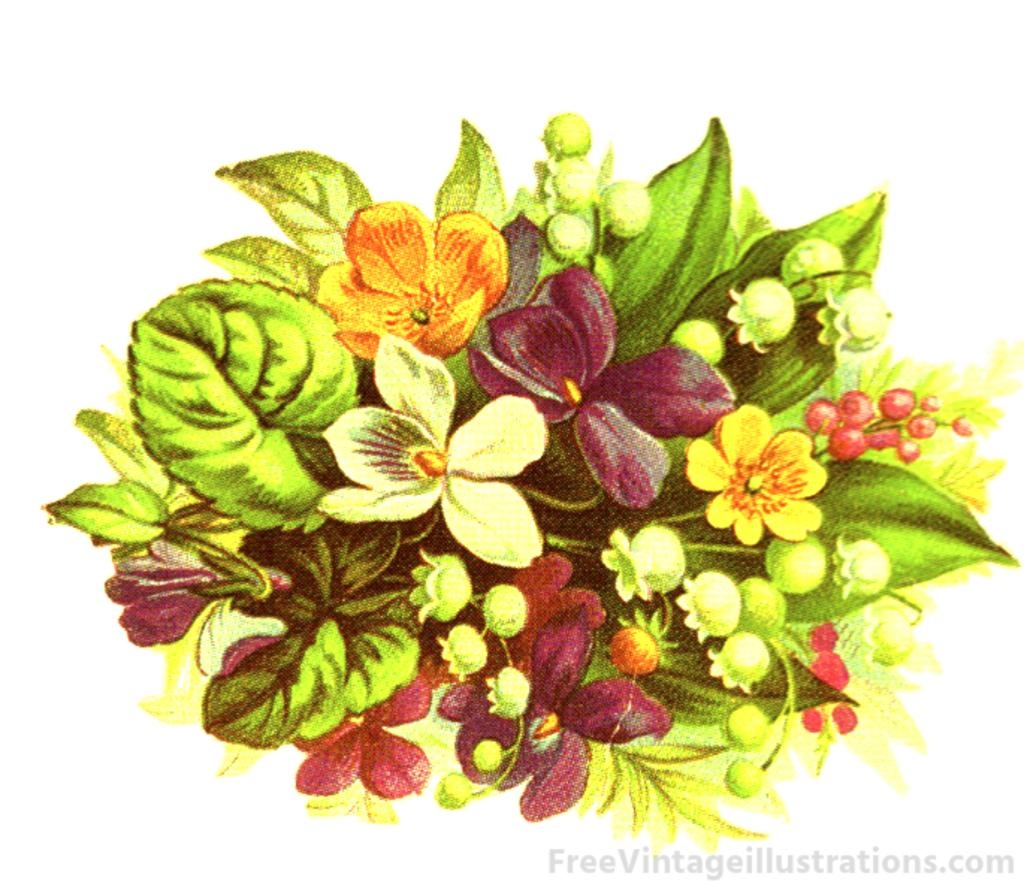What type of book is featured in the image? There is a flower book in the image. What can be found inside the flower book? The flower book contains different colors of flowers. Are there any other elements related to plants in the image? Yes, there are leaves in the image. Can you describe any additional features of the image? The image has a watermark. What color crayon is used to draw the point in the image? There is no crayon or drawing of a point present in the image. How does the profit from the flower book sales affect the image? The image does not depict any financial transactions or sales, so the profit from the flower book sales does not affect the image. 